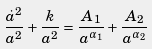<formula> <loc_0><loc_0><loc_500><loc_500>\frac { \dot { a } ^ { 2 } } { a ^ { 2 } } + \frac { k } { a ^ { 2 } } = \frac { A _ { 1 } } { a ^ { \alpha _ { 1 } } } + \frac { A _ { 2 } } { a ^ { \alpha _ { 2 } } }</formula> 